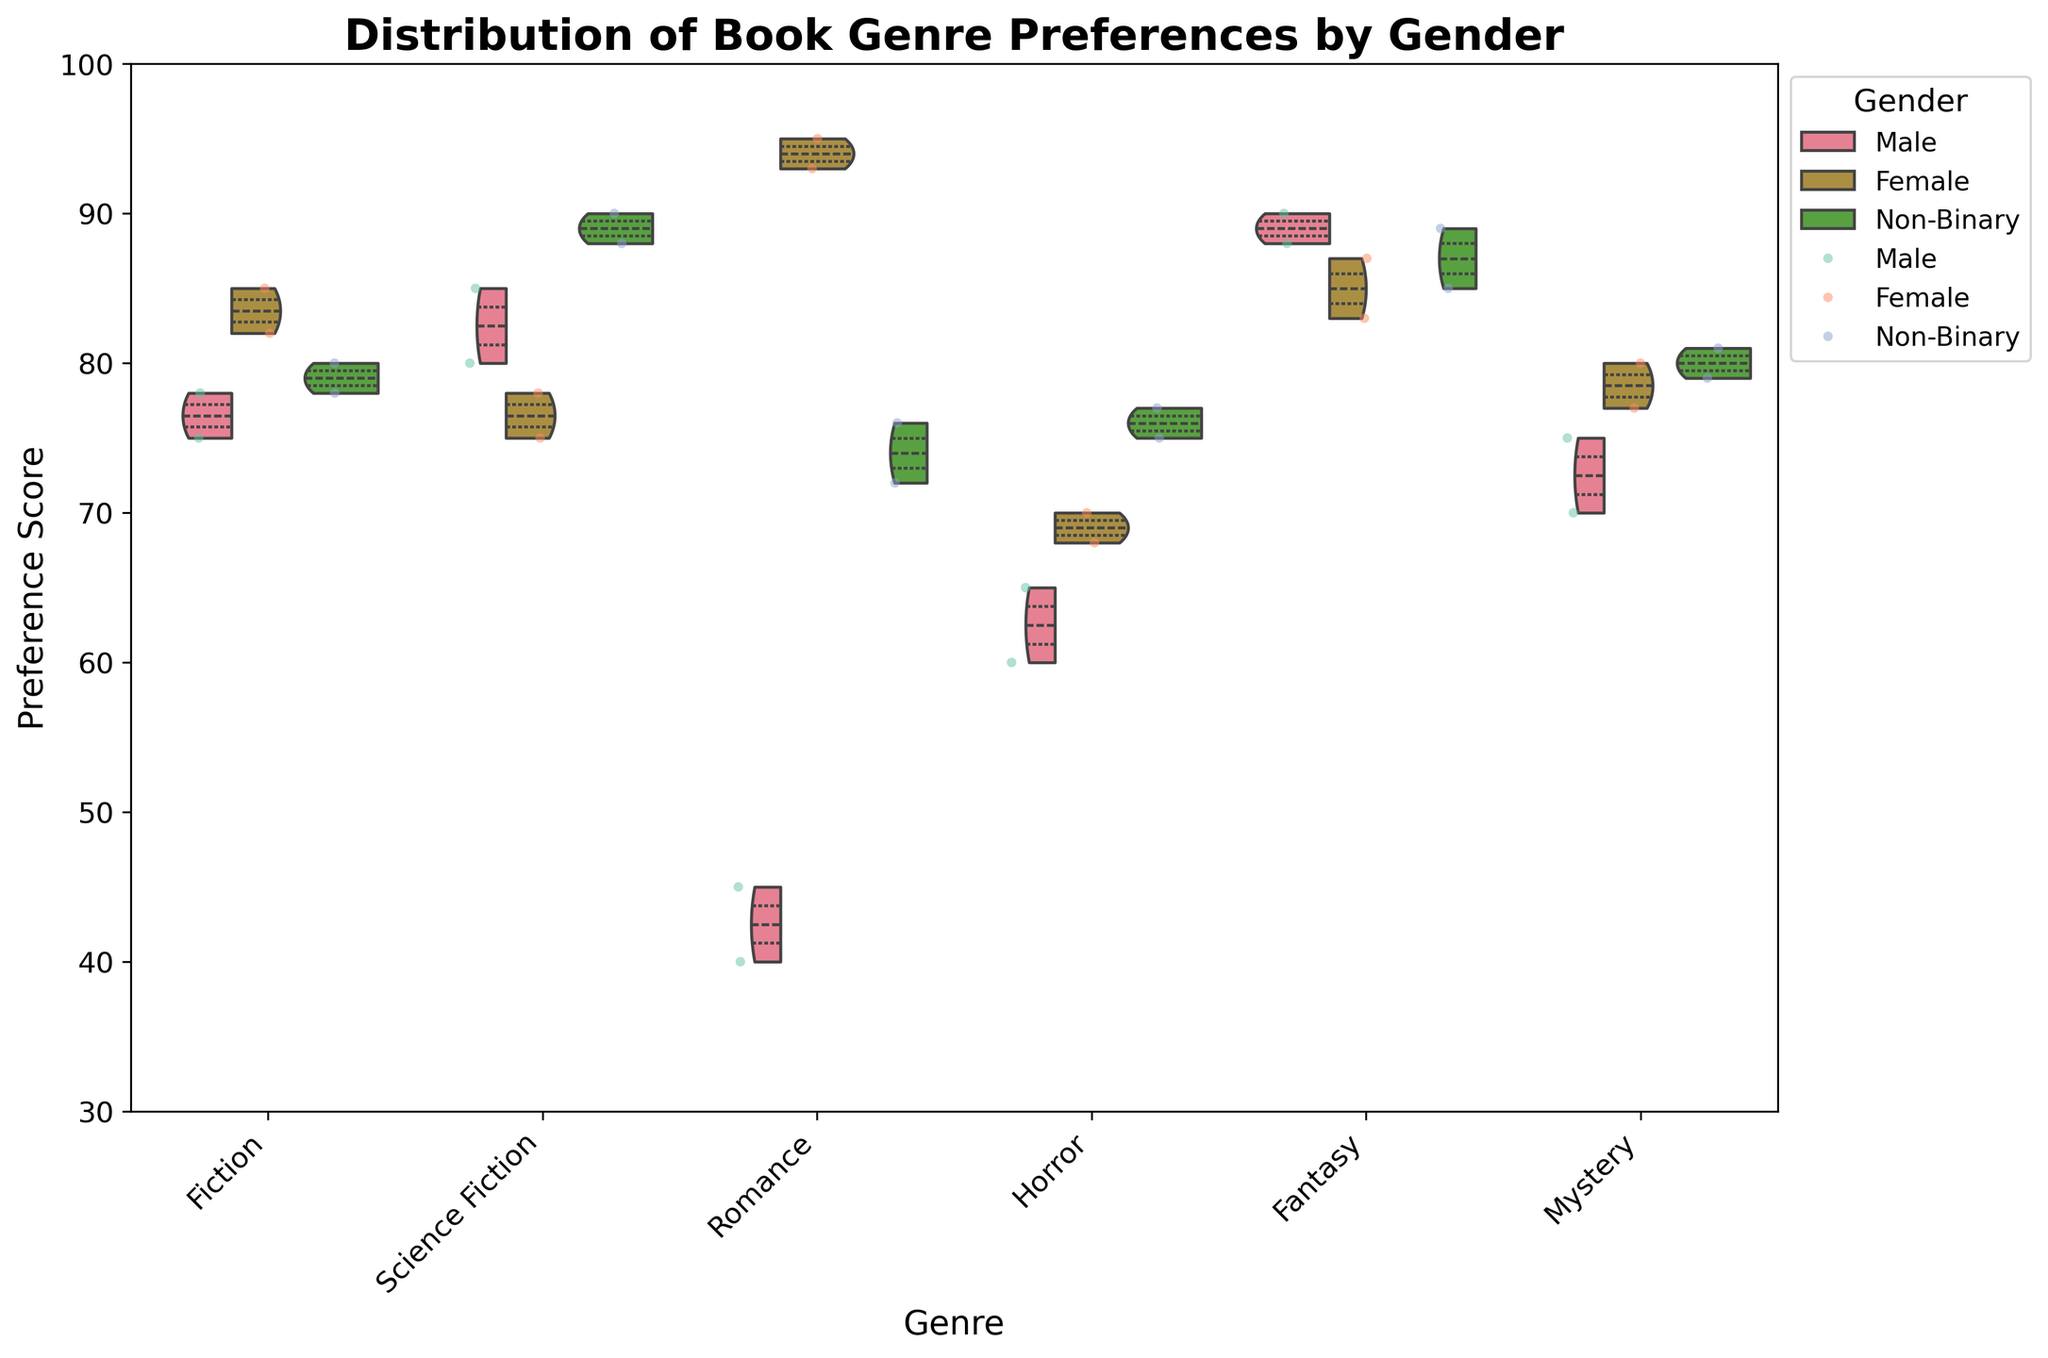What is the title of the figure? The title is located at the top of the figure and is written in bold and large font size.
Answer: Distribution of Book Genre Preferences by Gender Which genre has the highest preference score on average for Females? By examining the heights of the violin plots and the inner quartile lines, the Romance genre shows the consistently highest preference scores for Females.
Answer: Romance What is the median preference score for Males in the Fantasy genre? The inner quartile line within the violin plot for Males in the Fantasy genre indicates the median. For Males, this line appears roughly around 89.
Answer: 89 Which gender has the smallest range of preference scores for the Mystery genre? The range is determined by the spread of the violin plot along the y-axis. For the Mystery genre, Non-Binary shows the narrowest spread, indicating the smallest range.
Answer: Non-Binary How do the preference scores of Females and Non-Binary individuals for Science Fiction compare? Looking at the height and spread of the violin plots, Females generally have lower preference scores for Science Fiction compared to Non-Binary individuals.
Answer: Non-Binary has higher scores Does any genre show a significant overlap in preference scores between different genders? By comparing the overlapping areas of the violin plots for each genre, Fiction and Fantasy show significant overlaps between the three genders, indicating similar preference scores.
Answer: Fiction and Fantasy What is the highest individual preference score recorded in the data? Referring to the top-most points of all the jittered scatter points, the highest individual score is 95 in the Romance genre for Females.
Answer: 95 In the Horror genre, which gender has the highest median preference score? The inner line within the violin indicates the median, and for Horror, Non-Binary individuals have the highest median preference score as represented by the inner quartile line in their respective violin plot.
Answer: Non-Binary What is the general trend observed for Male preference scores across all genres? Examining the violin plots and jittered points, across most genres, Males tend to have a lower and more varied range of preference scores.
Answer: Lower and varied range 